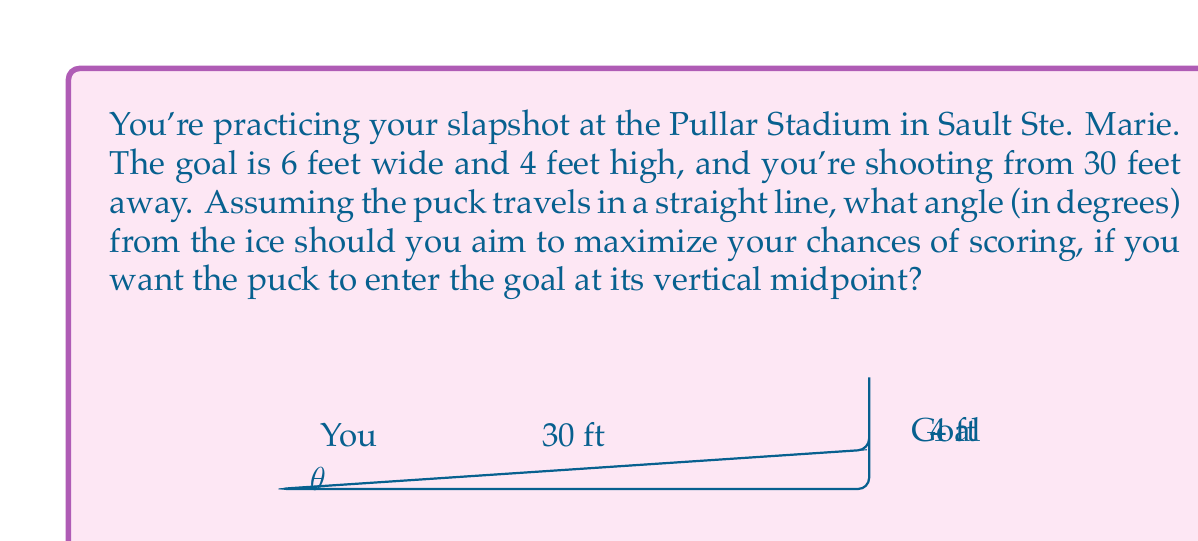What is the answer to this math problem? Let's approach this step-by-step:

1) First, we need to find the height of the middle of the goal. Since the goal is 4 feet high, its midpoint is at 2 feet.

2) We can now treat this as a right triangle problem. We have:
   - The adjacent side (distance to goal) = 30 feet
   - The opposite side (height to midpoint of goal) = 2 feet

3) We need to find the angle $\theta$ between the ice and the path of the puck.

4) In a right triangle, $\tan(\theta) = \frac{\text{opposite}}{\text{adjacent}}$

5) Therefore:

   $$\tan(\theta) = \frac{2}{30} = \frac{1}{15}$$

6) To find $\theta$, we need to take the inverse tangent (arctan or $\tan^{-1}$) of both sides:

   $$\theta = \tan^{-1}(\frac{1}{15})$$

7) Using a calculator or computer, we can evaluate this:

   $$\theta \approx 3.81^\circ$$

8) Rounding to two decimal places, we get 3.81°.

This angle will ensure that the puck enters the goal at its vertical midpoint, maximizing the chances of scoring by giving equal margins of error above and below the puck's trajectory.
Answer: $3.81^\circ$ 